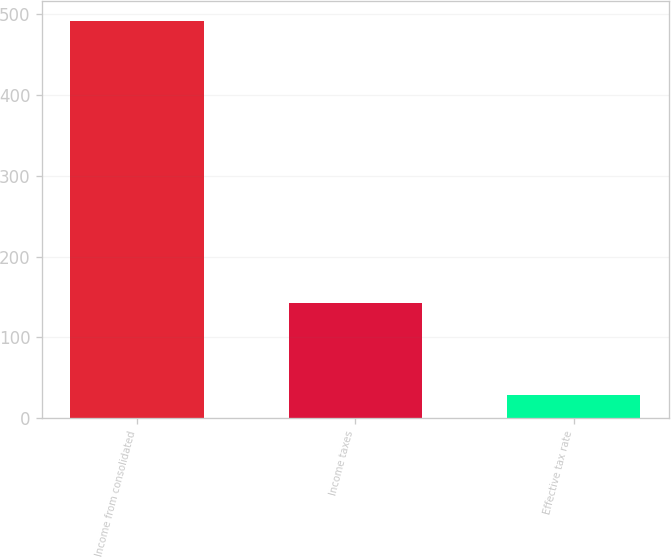<chart> <loc_0><loc_0><loc_500><loc_500><bar_chart><fcel>Income from consolidated<fcel>Income taxes<fcel>Effective tax rate<nl><fcel>491.4<fcel>142.6<fcel>29<nl></chart> 